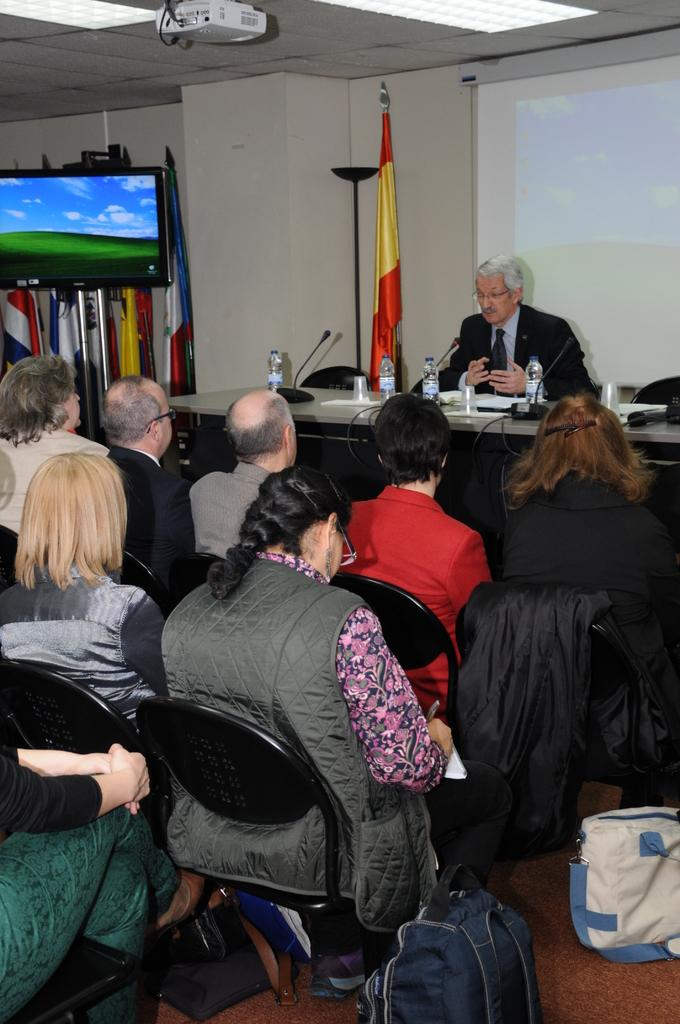What are the people in the image doing? There are persons sitting on chairs in the image. What electronic device is present in the image? There is a television in the image. What other device related to visual media can be seen in the image? There is a projector in the image. What is used to display the projected image in the room? There is a projector screen in the image. What type of pie is being served on the table in the image? There is no table or pie present in the image. What observation can be made about the persons sitting on chairs in the image? The provided facts do not allow for any observations about the persons sitting on chairs beyond their presence in the image. 